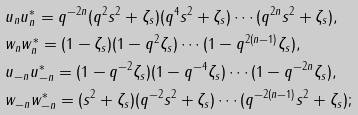<formula> <loc_0><loc_0><loc_500><loc_500>& u _ { n } u _ { n } ^ { * } = q ^ { - 2 n } ( q ^ { 2 } s ^ { 2 } + \zeta _ { s } ) ( q ^ { 4 } s ^ { 2 } + \zeta _ { s } ) \cdots ( q ^ { 2 n } s ^ { 2 } + \zeta _ { s } ) , \\ & w _ { n } w _ { n } ^ { * } = ( 1 - \zeta _ { s } ) ( 1 - q ^ { 2 } \zeta _ { s } ) \cdots ( 1 - q ^ { 2 ( n - 1 ) } \zeta _ { s } ) , \\ & u _ { - n } u _ { - n } ^ { * } = ( 1 - q ^ { - 2 } \zeta _ { s } ) ( 1 - q ^ { - 4 } \zeta _ { s } ) \cdots ( 1 - q ^ { - 2 n } \zeta _ { s } ) , \\ & w _ { - n } w _ { - n } ^ { * } = ( s ^ { 2 } + \zeta _ { s } ) ( q ^ { - 2 } s ^ { 2 } + \zeta _ { s } ) \cdots ( q ^ { - 2 ( n - 1 ) } s ^ { 2 } + \zeta _ { s } ) ;</formula> 